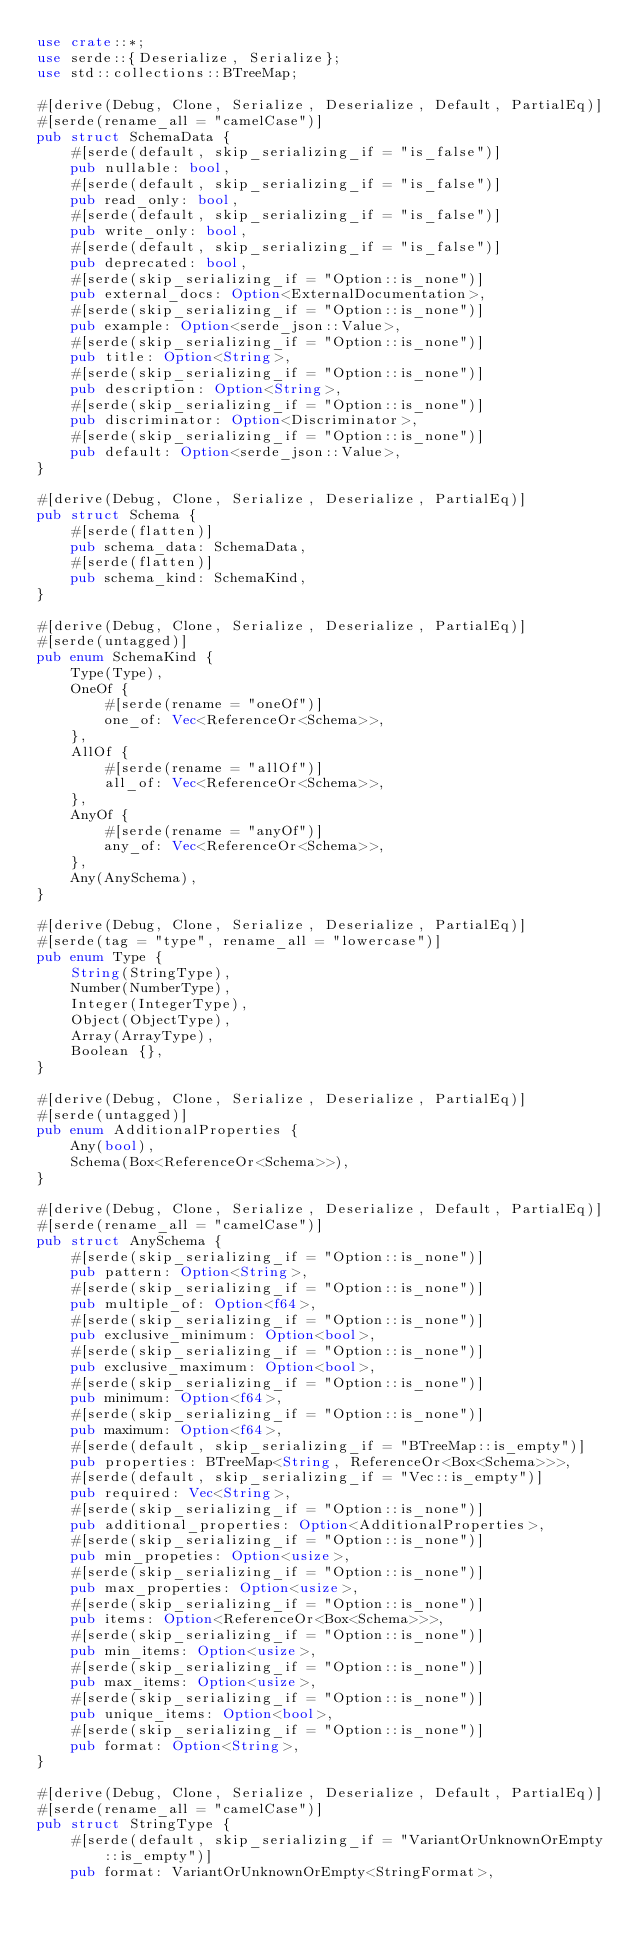Convert code to text. <code><loc_0><loc_0><loc_500><loc_500><_Rust_>use crate::*;
use serde::{Deserialize, Serialize};
use std::collections::BTreeMap;

#[derive(Debug, Clone, Serialize, Deserialize, Default, PartialEq)]
#[serde(rename_all = "camelCase")]
pub struct SchemaData {
    #[serde(default, skip_serializing_if = "is_false")]
    pub nullable: bool,
    #[serde(default, skip_serializing_if = "is_false")]
    pub read_only: bool,
    #[serde(default, skip_serializing_if = "is_false")]
    pub write_only: bool,
    #[serde(default, skip_serializing_if = "is_false")]
    pub deprecated: bool,
    #[serde(skip_serializing_if = "Option::is_none")]
    pub external_docs: Option<ExternalDocumentation>,
    #[serde(skip_serializing_if = "Option::is_none")]
    pub example: Option<serde_json::Value>,
    #[serde(skip_serializing_if = "Option::is_none")]
    pub title: Option<String>,
    #[serde(skip_serializing_if = "Option::is_none")]
    pub description: Option<String>,
    #[serde(skip_serializing_if = "Option::is_none")]
    pub discriminator: Option<Discriminator>,
    #[serde(skip_serializing_if = "Option::is_none")]
    pub default: Option<serde_json::Value>,
}

#[derive(Debug, Clone, Serialize, Deserialize, PartialEq)]
pub struct Schema {
    #[serde(flatten)]
    pub schema_data: SchemaData,
    #[serde(flatten)]
    pub schema_kind: SchemaKind,
}

#[derive(Debug, Clone, Serialize, Deserialize, PartialEq)]
#[serde(untagged)]
pub enum SchemaKind {
    Type(Type),
    OneOf {
        #[serde(rename = "oneOf")]
        one_of: Vec<ReferenceOr<Schema>>,
    },
    AllOf {
        #[serde(rename = "allOf")]
        all_of: Vec<ReferenceOr<Schema>>,
    },
    AnyOf {
        #[serde(rename = "anyOf")]
        any_of: Vec<ReferenceOr<Schema>>,
    },
    Any(AnySchema),
}

#[derive(Debug, Clone, Serialize, Deserialize, PartialEq)]
#[serde(tag = "type", rename_all = "lowercase")]
pub enum Type {
    String(StringType),
    Number(NumberType),
    Integer(IntegerType),
    Object(ObjectType),
    Array(ArrayType),
    Boolean {},
}

#[derive(Debug, Clone, Serialize, Deserialize, PartialEq)]
#[serde(untagged)]
pub enum AdditionalProperties {
    Any(bool),
    Schema(Box<ReferenceOr<Schema>>),
}

#[derive(Debug, Clone, Serialize, Deserialize, Default, PartialEq)]
#[serde(rename_all = "camelCase")]
pub struct AnySchema {
    #[serde(skip_serializing_if = "Option::is_none")]
    pub pattern: Option<String>,
    #[serde(skip_serializing_if = "Option::is_none")]
    pub multiple_of: Option<f64>,
    #[serde(skip_serializing_if = "Option::is_none")]
    pub exclusive_minimum: Option<bool>,
    #[serde(skip_serializing_if = "Option::is_none")]
    pub exclusive_maximum: Option<bool>,
    #[serde(skip_serializing_if = "Option::is_none")]
    pub minimum: Option<f64>,
    #[serde(skip_serializing_if = "Option::is_none")]
    pub maximum: Option<f64>,
    #[serde(default, skip_serializing_if = "BTreeMap::is_empty")]
    pub properties: BTreeMap<String, ReferenceOr<Box<Schema>>>,
    #[serde(default, skip_serializing_if = "Vec::is_empty")]
    pub required: Vec<String>,
    #[serde(skip_serializing_if = "Option::is_none")]
    pub additional_properties: Option<AdditionalProperties>,
    #[serde(skip_serializing_if = "Option::is_none")]
    pub min_propeties: Option<usize>,
    #[serde(skip_serializing_if = "Option::is_none")]
    pub max_properties: Option<usize>,
    #[serde(skip_serializing_if = "Option::is_none")]
    pub items: Option<ReferenceOr<Box<Schema>>>,
    #[serde(skip_serializing_if = "Option::is_none")]
    pub min_items: Option<usize>,
    #[serde(skip_serializing_if = "Option::is_none")]
    pub max_items: Option<usize>,
    #[serde(skip_serializing_if = "Option::is_none")]
    pub unique_items: Option<bool>,
    #[serde(skip_serializing_if = "Option::is_none")]
    pub format: Option<String>,
}

#[derive(Debug, Clone, Serialize, Deserialize, Default, PartialEq)]
#[serde(rename_all = "camelCase")]
pub struct StringType {
    #[serde(default, skip_serializing_if = "VariantOrUnknownOrEmpty::is_empty")]
    pub format: VariantOrUnknownOrEmpty<StringFormat>,</code> 